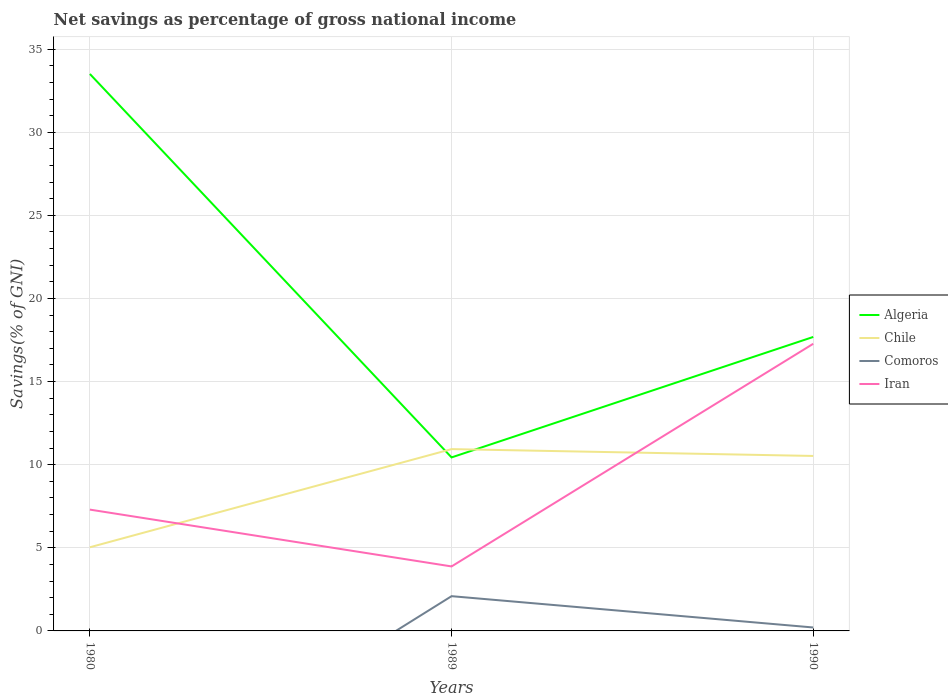How many different coloured lines are there?
Ensure brevity in your answer.  4. What is the total total savings in Chile in the graph?
Provide a succinct answer. -5.9. What is the difference between the highest and the second highest total savings in Comoros?
Offer a very short reply. 2.09. What is the difference between the highest and the lowest total savings in Chile?
Offer a terse response. 2. How many lines are there?
Offer a terse response. 4. What is the difference between two consecutive major ticks on the Y-axis?
Keep it short and to the point. 5. Does the graph contain any zero values?
Offer a terse response. Yes. Where does the legend appear in the graph?
Offer a terse response. Center right. How are the legend labels stacked?
Your answer should be compact. Vertical. What is the title of the graph?
Your response must be concise. Net savings as percentage of gross national income. What is the label or title of the Y-axis?
Provide a succinct answer. Savings(% of GNI). What is the Savings(% of GNI) in Algeria in 1980?
Provide a succinct answer. 33.51. What is the Savings(% of GNI) of Chile in 1980?
Your answer should be compact. 5.03. What is the Savings(% of GNI) in Comoros in 1980?
Keep it short and to the point. 0. What is the Savings(% of GNI) in Iran in 1980?
Your response must be concise. 7.3. What is the Savings(% of GNI) in Algeria in 1989?
Offer a terse response. 10.44. What is the Savings(% of GNI) of Chile in 1989?
Ensure brevity in your answer.  10.94. What is the Savings(% of GNI) of Comoros in 1989?
Make the answer very short. 2.09. What is the Savings(% of GNI) of Iran in 1989?
Your answer should be compact. 3.88. What is the Savings(% of GNI) in Algeria in 1990?
Offer a terse response. 17.69. What is the Savings(% of GNI) of Chile in 1990?
Offer a very short reply. 10.53. What is the Savings(% of GNI) of Comoros in 1990?
Make the answer very short. 0.21. What is the Savings(% of GNI) of Iran in 1990?
Keep it short and to the point. 17.28. Across all years, what is the maximum Savings(% of GNI) in Algeria?
Make the answer very short. 33.51. Across all years, what is the maximum Savings(% of GNI) in Chile?
Your answer should be very brief. 10.94. Across all years, what is the maximum Savings(% of GNI) in Comoros?
Your response must be concise. 2.09. Across all years, what is the maximum Savings(% of GNI) of Iran?
Offer a terse response. 17.28. Across all years, what is the minimum Savings(% of GNI) in Algeria?
Ensure brevity in your answer.  10.44. Across all years, what is the minimum Savings(% of GNI) of Chile?
Offer a very short reply. 5.03. Across all years, what is the minimum Savings(% of GNI) in Comoros?
Your answer should be compact. 0. Across all years, what is the minimum Savings(% of GNI) of Iran?
Your answer should be compact. 3.88. What is the total Savings(% of GNI) in Algeria in the graph?
Provide a succinct answer. 61.63. What is the total Savings(% of GNI) of Chile in the graph?
Your answer should be compact. 26.5. What is the total Savings(% of GNI) in Comoros in the graph?
Your answer should be compact. 2.3. What is the total Savings(% of GNI) of Iran in the graph?
Offer a terse response. 28.45. What is the difference between the Savings(% of GNI) of Algeria in 1980 and that in 1989?
Provide a succinct answer. 23.07. What is the difference between the Savings(% of GNI) in Chile in 1980 and that in 1989?
Provide a short and direct response. -5.91. What is the difference between the Savings(% of GNI) in Iran in 1980 and that in 1989?
Offer a very short reply. 3.42. What is the difference between the Savings(% of GNI) in Algeria in 1980 and that in 1990?
Give a very brief answer. 15.82. What is the difference between the Savings(% of GNI) of Chile in 1980 and that in 1990?
Provide a succinct answer. -5.49. What is the difference between the Savings(% of GNI) in Iran in 1980 and that in 1990?
Your answer should be compact. -9.98. What is the difference between the Savings(% of GNI) of Algeria in 1989 and that in 1990?
Keep it short and to the point. -7.25. What is the difference between the Savings(% of GNI) in Chile in 1989 and that in 1990?
Offer a very short reply. 0.41. What is the difference between the Savings(% of GNI) in Comoros in 1989 and that in 1990?
Give a very brief answer. 1.88. What is the difference between the Savings(% of GNI) of Iran in 1989 and that in 1990?
Ensure brevity in your answer.  -13.4. What is the difference between the Savings(% of GNI) in Algeria in 1980 and the Savings(% of GNI) in Chile in 1989?
Provide a short and direct response. 22.57. What is the difference between the Savings(% of GNI) of Algeria in 1980 and the Savings(% of GNI) of Comoros in 1989?
Provide a succinct answer. 31.42. What is the difference between the Savings(% of GNI) in Algeria in 1980 and the Savings(% of GNI) in Iran in 1989?
Your response must be concise. 29.63. What is the difference between the Savings(% of GNI) of Chile in 1980 and the Savings(% of GNI) of Comoros in 1989?
Ensure brevity in your answer.  2.94. What is the difference between the Savings(% of GNI) in Chile in 1980 and the Savings(% of GNI) in Iran in 1989?
Provide a succinct answer. 1.15. What is the difference between the Savings(% of GNI) in Algeria in 1980 and the Savings(% of GNI) in Chile in 1990?
Offer a terse response. 22.98. What is the difference between the Savings(% of GNI) of Algeria in 1980 and the Savings(% of GNI) of Comoros in 1990?
Keep it short and to the point. 33.3. What is the difference between the Savings(% of GNI) in Algeria in 1980 and the Savings(% of GNI) in Iran in 1990?
Offer a terse response. 16.23. What is the difference between the Savings(% of GNI) of Chile in 1980 and the Savings(% of GNI) of Comoros in 1990?
Offer a terse response. 4.83. What is the difference between the Savings(% of GNI) of Chile in 1980 and the Savings(% of GNI) of Iran in 1990?
Provide a short and direct response. -12.24. What is the difference between the Savings(% of GNI) in Algeria in 1989 and the Savings(% of GNI) in Chile in 1990?
Offer a very short reply. -0.09. What is the difference between the Savings(% of GNI) of Algeria in 1989 and the Savings(% of GNI) of Comoros in 1990?
Provide a succinct answer. 10.23. What is the difference between the Savings(% of GNI) of Algeria in 1989 and the Savings(% of GNI) of Iran in 1990?
Give a very brief answer. -6.84. What is the difference between the Savings(% of GNI) in Chile in 1989 and the Savings(% of GNI) in Comoros in 1990?
Your response must be concise. 10.73. What is the difference between the Savings(% of GNI) of Chile in 1989 and the Savings(% of GNI) of Iran in 1990?
Offer a very short reply. -6.34. What is the difference between the Savings(% of GNI) of Comoros in 1989 and the Savings(% of GNI) of Iran in 1990?
Offer a very short reply. -15.19. What is the average Savings(% of GNI) of Algeria per year?
Your answer should be compact. 20.54. What is the average Savings(% of GNI) in Chile per year?
Your response must be concise. 8.83. What is the average Savings(% of GNI) in Comoros per year?
Give a very brief answer. 0.77. What is the average Savings(% of GNI) in Iran per year?
Your answer should be compact. 9.48. In the year 1980, what is the difference between the Savings(% of GNI) of Algeria and Savings(% of GNI) of Chile?
Your response must be concise. 28.47. In the year 1980, what is the difference between the Savings(% of GNI) of Algeria and Savings(% of GNI) of Iran?
Offer a terse response. 26.21. In the year 1980, what is the difference between the Savings(% of GNI) in Chile and Savings(% of GNI) in Iran?
Your answer should be very brief. -2.27. In the year 1989, what is the difference between the Savings(% of GNI) of Algeria and Savings(% of GNI) of Chile?
Provide a short and direct response. -0.5. In the year 1989, what is the difference between the Savings(% of GNI) of Algeria and Savings(% of GNI) of Comoros?
Offer a very short reply. 8.35. In the year 1989, what is the difference between the Savings(% of GNI) of Algeria and Savings(% of GNI) of Iran?
Make the answer very short. 6.56. In the year 1989, what is the difference between the Savings(% of GNI) of Chile and Savings(% of GNI) of Comoros?
Give a very brief answer. 8.85. In the year 1989, what is the difference between the Savings(% of GNI) in Chile and Savings(% of GNI) in Iran?
Give a very brief answer. 7.06. In the year 1989, what is the difference between the Savings(% of GNI) in Comoros and Savings(% of GNI) in Iran?
Your response must be concise. -1.79. In the year 1990, what is the difference between the Savings(% of GNI) of Algeria and Savings(% of GNI) of Chile?
Keep it short and to the point. 7.16. In the year 1990, what is the difference between the Savings(% of GNI) of Algeria and Savings(% of GNI) of Comoros?
Give a very brief answer. 17.48. In the year 1990, what is the difference between the Savings(% of GNI) in Algeria and Savings(% of GNI) in Iran?
Give a very brief answer. 0.41. In the year 1990, what is the difference between the Savings(% of GNI) of Chile and Savings(% of GNI) of Comoros?
Ensure brevity in your answer.  10.32. In the year 1990, what is the difference between the Savings(% of GNI) in Chile and Savings(% of GNI) in Iran?
Give a very brief answer. -6.75. In the year 1990, what is the difference between the Savings(% of GNI) in Comoros and Savings(% of GNI) in Iran?
Give a very brief answer. -17.07. What is the ratio of the Savings(% of GNI) in Algeria in 1980 to that in 1989?
Keep it short and to the point. 3.21. What is the ratio of the Savings(% of GNI) of Chile in 1980 to that in 1989?
Give a very brief answer. 0.46. What is the ratio of the Savings(% of GNI) in Iran in 1980 to that in 1989?
Make the answer very short. 1.88. What is the ratio of the Savings(% of GNI) of Algeria in 1980 to that in 1990?
Offer a terse response. 1.89. What is the ratio of the Savings(% of GNI) in Chile in 1980 to that in 1990?
Your response must be concise. 0.48. What is the ratio of the Savings(% of GNI) in Iran in 1980 to that in 1990?
Your answer should be very brief. 0.42. What is the ratio of the Savings(% of GNI) in Algeria in 1989 to that in 1990?
Offer a terse response. 0.59. What is the ratio of the Savings(% of GNI) of Chile in 1989 to that in 1990?
Give a very brief answer. 1.04. What is the ratio of the Savings(% of GNI) of Comoros in 1989 to that in 1990?
Your answer should be very brief. 10.09. What is the ratio of the Savings(% of GNI) in Iran in 1989 to that in 1990?
Provide a short and direct response. 0.22. What is the difference between the highest and the second highest Savings(% of GNI) in Algeria?
Provide a short and direct response. 15.82. What is the difference between the highest and the second highest Savings(% of GNI) of Chile?
Offer a terse response. 0.41. What is the difference between the highest and the second highest Savings(% of GNI) of Iran?
Make the answer very short. 9.98. What is the difference between the highest and the lowest Savings(% of GNI) of Algeria?
Offer a very short reply. 23.07. What is the difference between the highest and the lowest Savings(% of GNI) in Chile?
Offer a terse response. 5.91. What is the difference between the highest and the lowest Savings(% of GNI) of Comoros?
Give a very brief answer. 2.09. What is the difference between the highest and the lowest Savings(% of GNI) of Iran?
Ensure brevity in your answer.  13.4. 